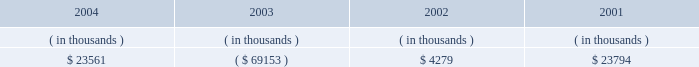Entergy arkansas , inc .
Management's financial discussion and analysis operating activities cash flow from operations increased $ 8.8 million in 2004 compared to 2003 primarily due to income tax benefits received in 2004 , and increased recovery of deferred fuel costs .
This increase was substantially offset by money pool activity .
In 2003 , the domestic utility companies and system energy filed , with the irs , a change in tax accounting method notification for their respective calculations of cost of goods sold .
The adjustment implemented a simplified method of allocation of overhead to the production of electricity , which is provided under the irs capitalization regulations .
The cumulative adjustment placing these companies on the new methodology resulted in a $ 1.171 billion deduction for entergy arkansas on entergy's 2003 income tax return .
There was no cash benefit from the method change in 2003 .
In 2004 , entergy arkansas realized $ 173 million in cash tax benefit from the method change .
This tax accounting method change is an issue across the utility industry and will likely be challenged by the irs on audit .
As of december 31 , 2004 , entergy arkansas has a net operating loss ( nol ) carryforward for tax purposes of $ 766.9 million , principally resulting from the change in tax accounting method related to cost of goods sold .
If the tax accounting method change is sustained , entergy arkansas expects to utilize the nol carryforward through 2006 .
Cash flow from operations increased $ 80.1 million in 2003 compared to 2002 primarily due to income taxes paid of $ 2.2 million in 2003 compared to income taxes paid of $ 83.9 million in 2002 , and money pool activity .
This increase was partially offset by decreased recovery of deferred fuel costs in 2003 .
Entergy arkansas' receivables from or ( payables to ) the money pool were as follows as of december 31 for each of the following years: .
Money pool activity used $ 92.7 million of entergy arkansas' operating cash flow in 2004 , provided $ 73.4 million in 2003 , and provided $ 19.5 million in 2002 .
See note 4 to the domestic utility companies and system energy financial statements for a description of the money pool .
Investing activities the decrease of $ 68.1 million in net cash used in investing activities in 2004 compared to 2003 was primarily due to a decrease in construction expenditures resulting from less transmission upgrade work requested by merchant generators in 2004 combined with lower spending on customer support projects in 2004 .
The increase of $ 88.1 million in net cash used in investing activities in 2003 compared to 2002 was primarily due to an increase in construction expenditures of $ 57.4 million and the maturity of $ 38.4 million of other temporary investments in the first quarter of 2002 .
Construction expenditures increased in 2003 primarily due to the following : 2022 a ferc ruling that shifted responsibility for transmission upgrade work performed for independent power producers to entergy arkansas ; and 2022 the ano 1 steam generator , reactor vessel head , and transformer replacement project .
Financing activities the decrease of $ 90.7 million in net cash used in financing activities in 2004 compared to 2003 was primarily due to the net redemption of $ 2.4 million of long-term debt in 2004 compared to $ 109.3 million in 2003 , partially offset by the payment of $ 16.2 million more in common stock dividends during the same period. .
What is the percent change in receivables from or ( payables to ) the money pool from 2001 to 2002? 
Computations: ((23794 - 4279) / 4279)
Answer: 4.56065. 